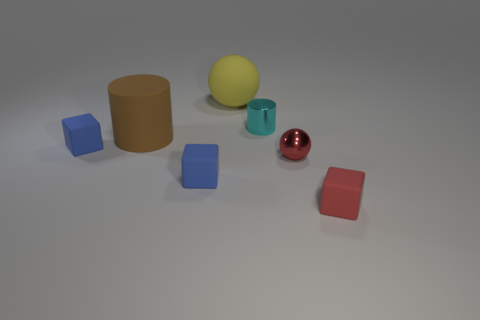What material is the tiny object that is the same color as the tiny metal ball?
Your answer should be compact. Rubber. What shape is the blue matte thing in front of the red metal ball?
Keep it short and to the point. Cube. How many other objects are there of the same shape as the red rubber thing?
Offer a very short reply. 2. Is the blue cube that is on the right side of the brown cylinder made of the same material as the tiny cyan cylinder?
Your response must be concise. No. Is the number of large brown rubber things that are behind the small red metal sphere the same as the number of yellow spheres in front of the red block?
Offer a very short reply. No. There is a red thing that is in front of the red shiny thing; what size is it?
Provide a succinct answer. Small. Is there a tiny blue sphere made of the same material as the yellow sphere?
Make the answer very short. No. There is a tiny metallic object right of the cyan cylinder; is its color the same as the matte ball?
Your response must be concise. No. Is the number of spheres that are to the right of the small red metal ball the same as the number of blue shiny objects?
Provide a short and direct response. Yes. Is there a block of the same color as the small metal ball?
Offer a terse response. Yes. 